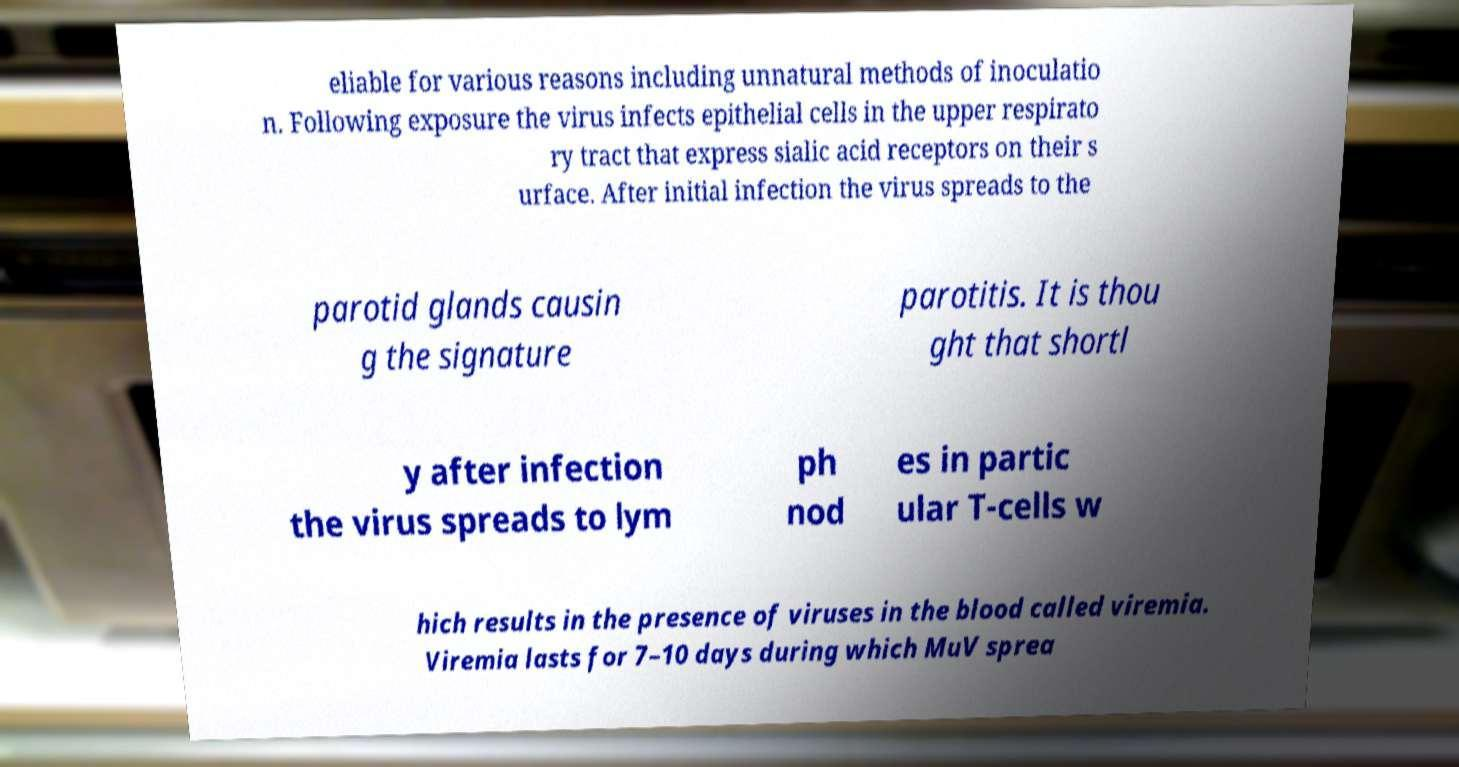Could you assist in decoding the text presented in this image and type it out clearly? eliable for various reasons including unnatural methods of inoculatio n. Following exposure the virus infects epithelial cells in the upper respirato ry tract that express sialic acid receptors on their s urface. After initial infection the virus spreads to the parotid glands causin g the signature parotitis. It is thou ght that shortl y after infection the virus spreads to lym ph nod es in partic ular T-cells w hich results in the presence of viruses in the blood called viremia. Viremia lasts for 7–10 days during which MuV sprea 